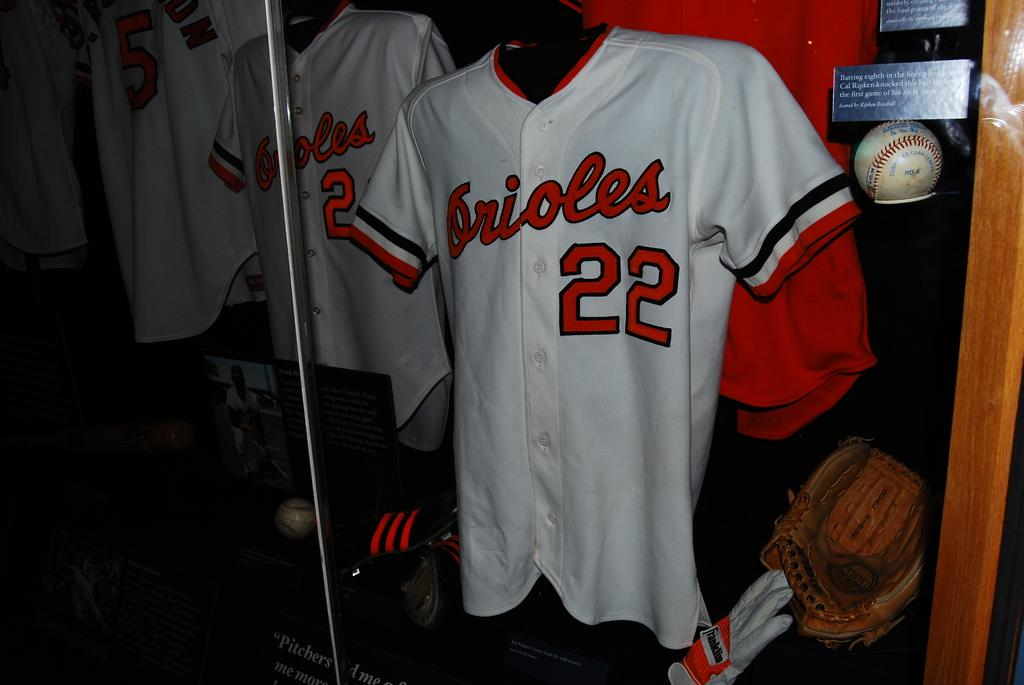<image>
Describe the image concisely. A white sports jersey with the number 22 on it 